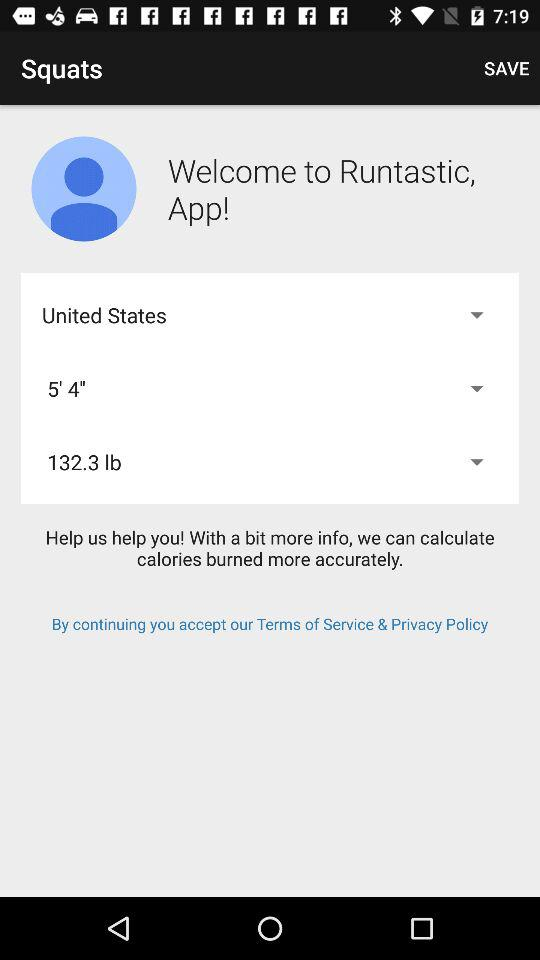What is the app name? The app name is "Runtastic". 